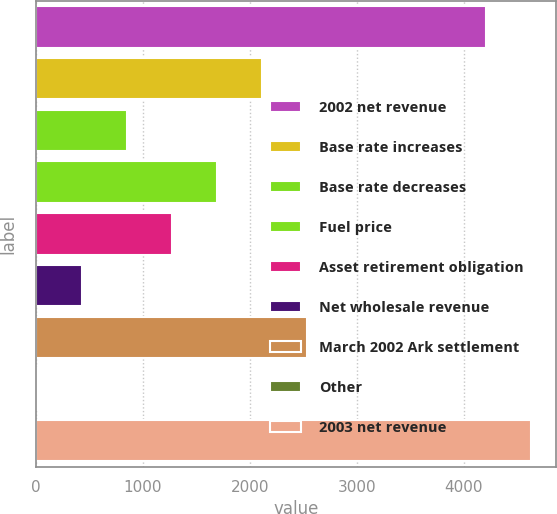Convert chart. <chart><loc_0><loc_0><loc_500><loc_500><bar_chart><fcel>2002 net revenue<fcel>Base rate increases<fcel>Base rate decreases<fcel>Fuel price<fcel>Asset retirement obligation<fcel>Net wholesale revenue<fcel>March 2002 Ark settlement<fcel>Other<fcel>2003 net revenue<nl><fcel>4209.6<fcel>2110.4<fcel>847.94<fcel>1689.58<fcel>1268.76<fcel>427.12<fcel>2531.22<fcel>6.3<fcel>4630.42<nl></chart> 